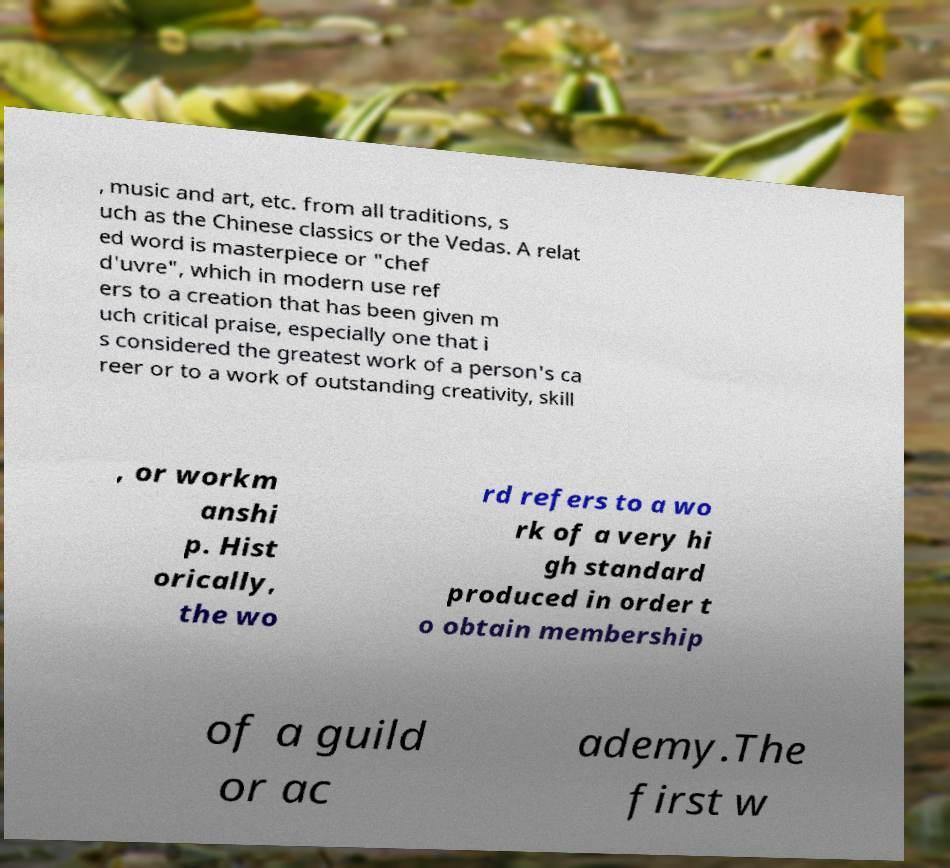Could you assist in decoding the text presented in this image and type it out clearly? , music and art, etc. from all traditions, s uch as the Chinese classics or the Vedas. A relat ed word is masterpiece or "chef d'uvre", which in modern use ref ers to a creation that has been given m uch critical praise, especially one that i s considered the greatest work of a person's ca reer or to a work of outstanding creativity, skill , or workm anshi p. Hist orically, the wo rd refers to a wo rk of a very hi gh standard produced in order t o obtain membership of a guild or ac ademy.The first w 